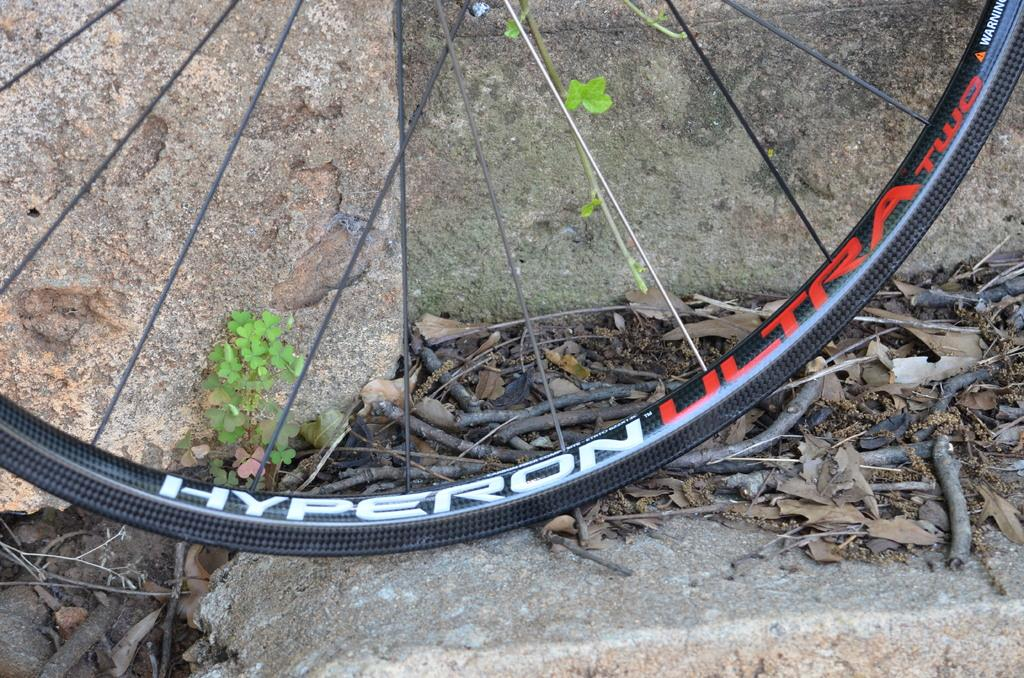What object is the main focus of the image? The main focus of the image is a wheel of a bicycle. What can be seen in the background of the image? There are rocks in the background of the image. What type of vegetation is visible in the image? There are plants visible in the image. What other objects can be seen in the image? There are twigs in the image. What type of music can be heard playing in the background of the image? There is no music present in the image, as it is a still photograph. 